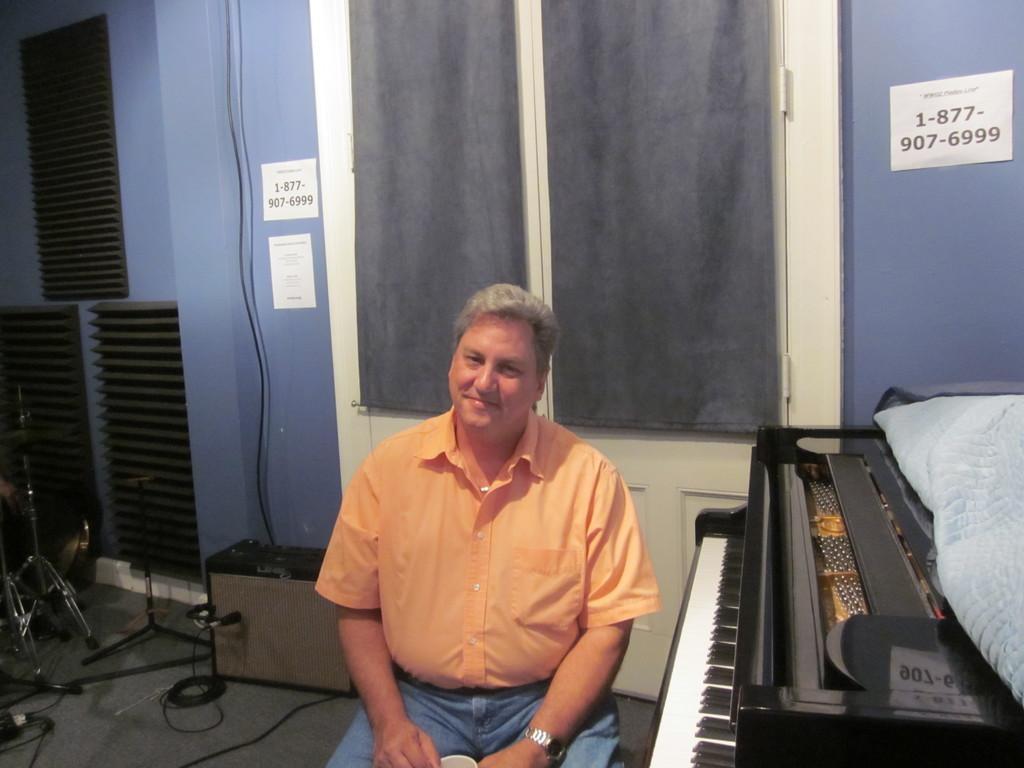In one or two sentences, can you explain what this image depicts? The image is taken in the room. In the center of the image there is a man sitting, he is smiling. On the right there is a piano. In the background there is a door, wall and some papers placed on the wall. 